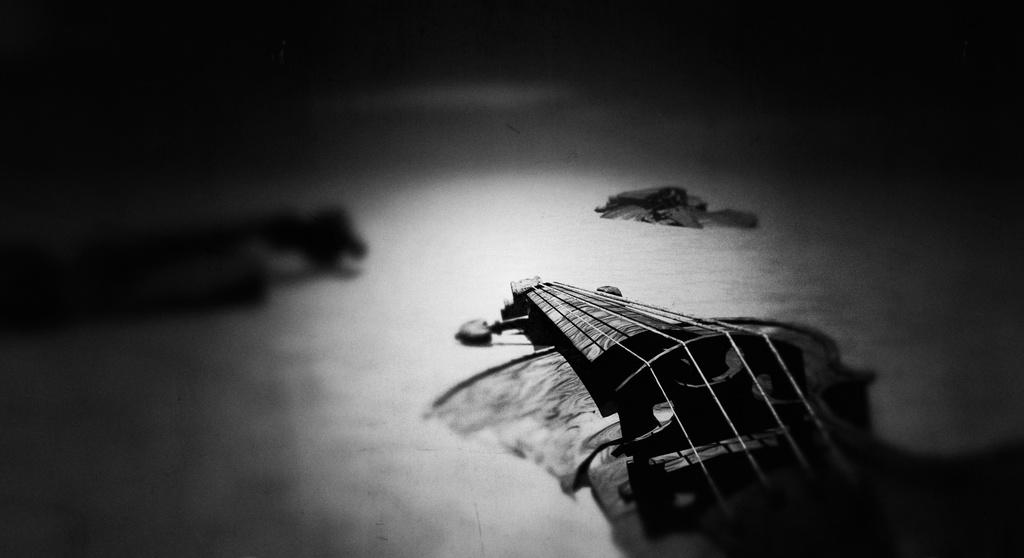What is the color scheme of the image? The image is black and white. What object can be seen in the image? There is a musical instrument in the image. What can be observed about the background of the image? The background of the image is dark. What type of reaction can be seen from the yarn in the image? There is no yarn present in the image, so it is not possible to observe any reaction from it. 